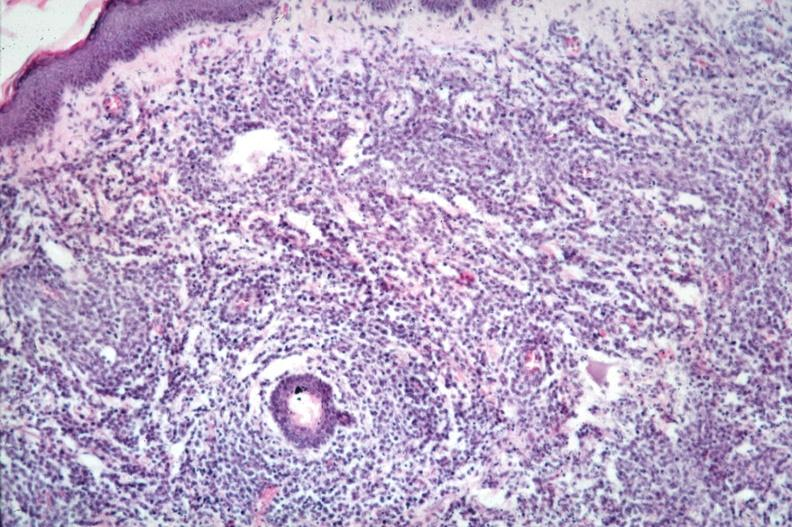does metastatic carcinoma breast show dermal lymphoma infiltrate?
Answer the question using a single word or phrase. No 